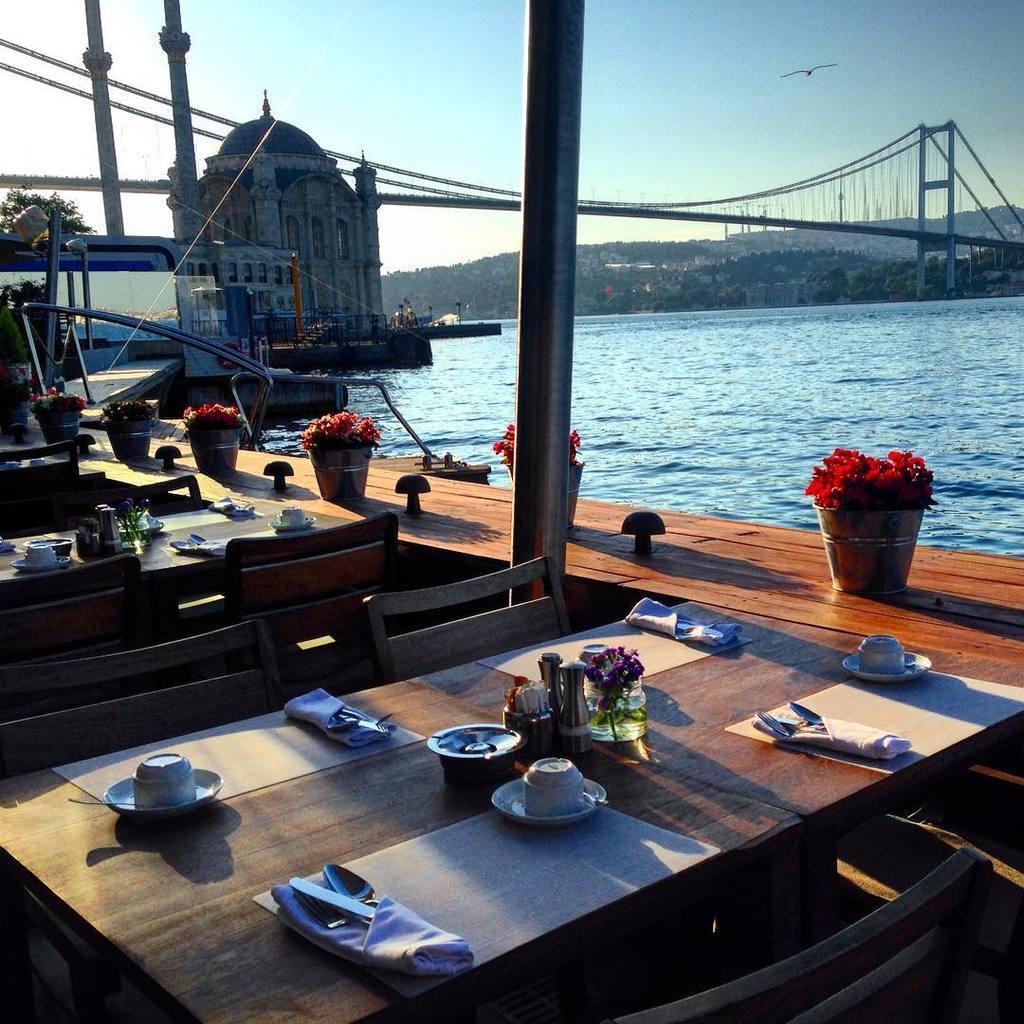Please provide a concise description of this image. In this picture we can see chairs,tables. On the table we can see cup,saucer,glass,flower,cloth,spoon. This is water. This is bridge,This is bird. This is sky. 